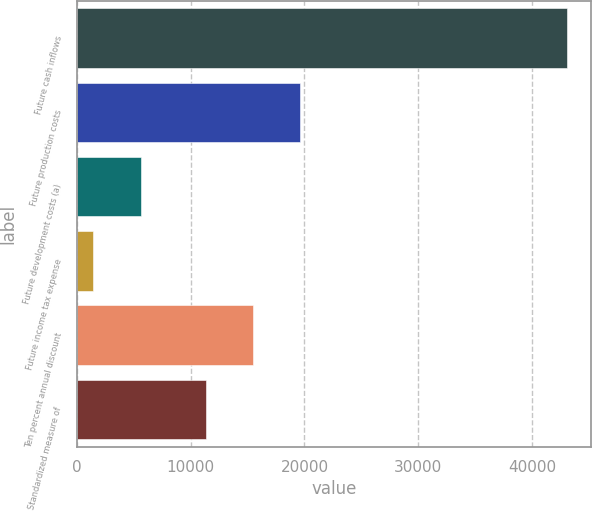<chart> <loc_0><loc_0><loc_500><loc_500><bar_chart><fcel>Future cash inflows<fcel>Future production costs<fcel>Future development costs (a)<fcel>Future income tax expense<fcel>Ten percent annual discount<fcel>Standardized measure of<nl><fcel>43057<fcel>19652.2<fcel>5620.6<fcel>1461<fcel>15492.6<fcel>11333<nl></chart> 